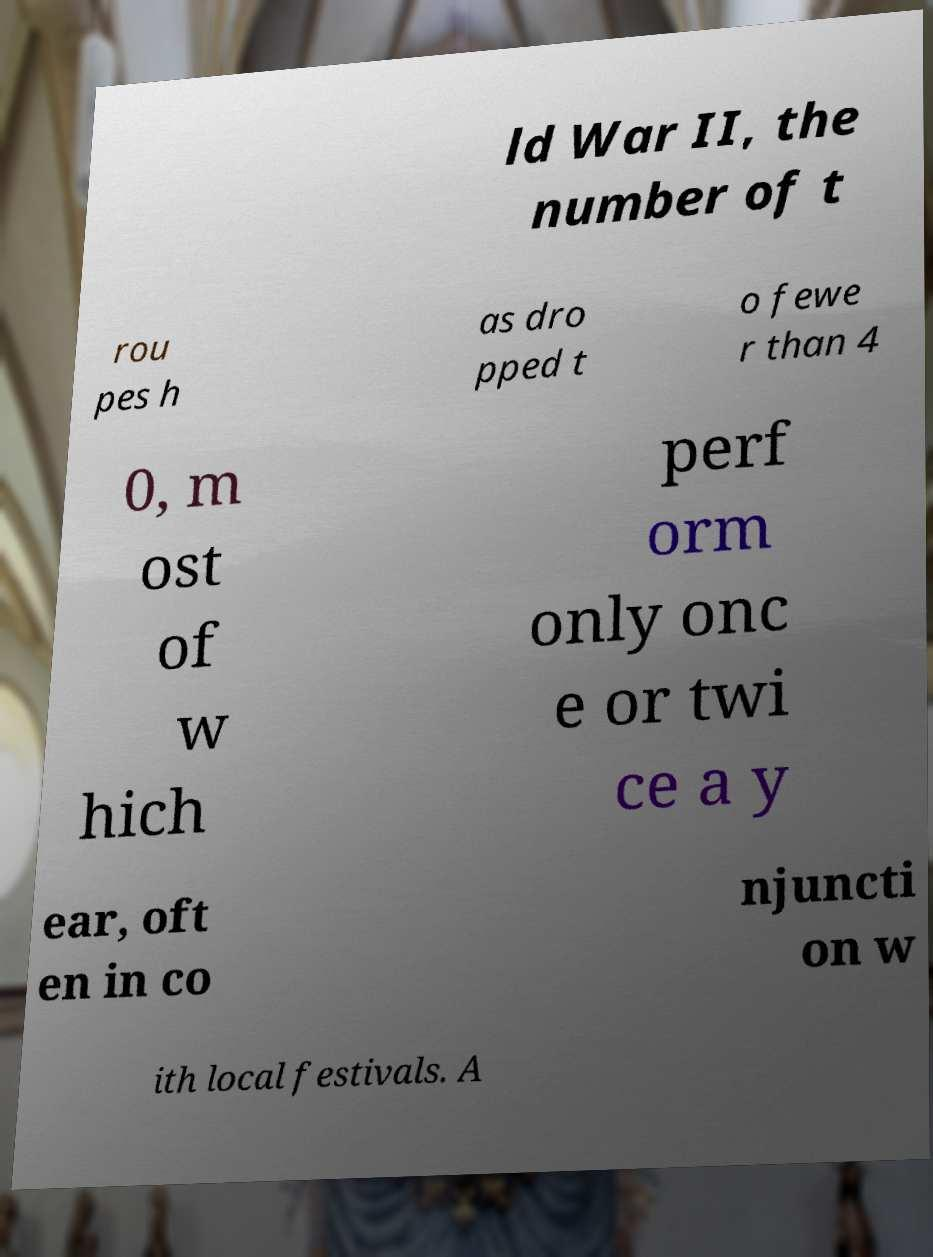Can you read and provide the text displayed in the image?This photo seems to have some interesting text. Can you extract and type it out for me? ld War II, the number of t rou pes h as dro pped t o fewe r than 4 0, m ost of w hich perf orm only onc e or twi ce a y ear, oft en in co njuncti on w ith local festivals. A 